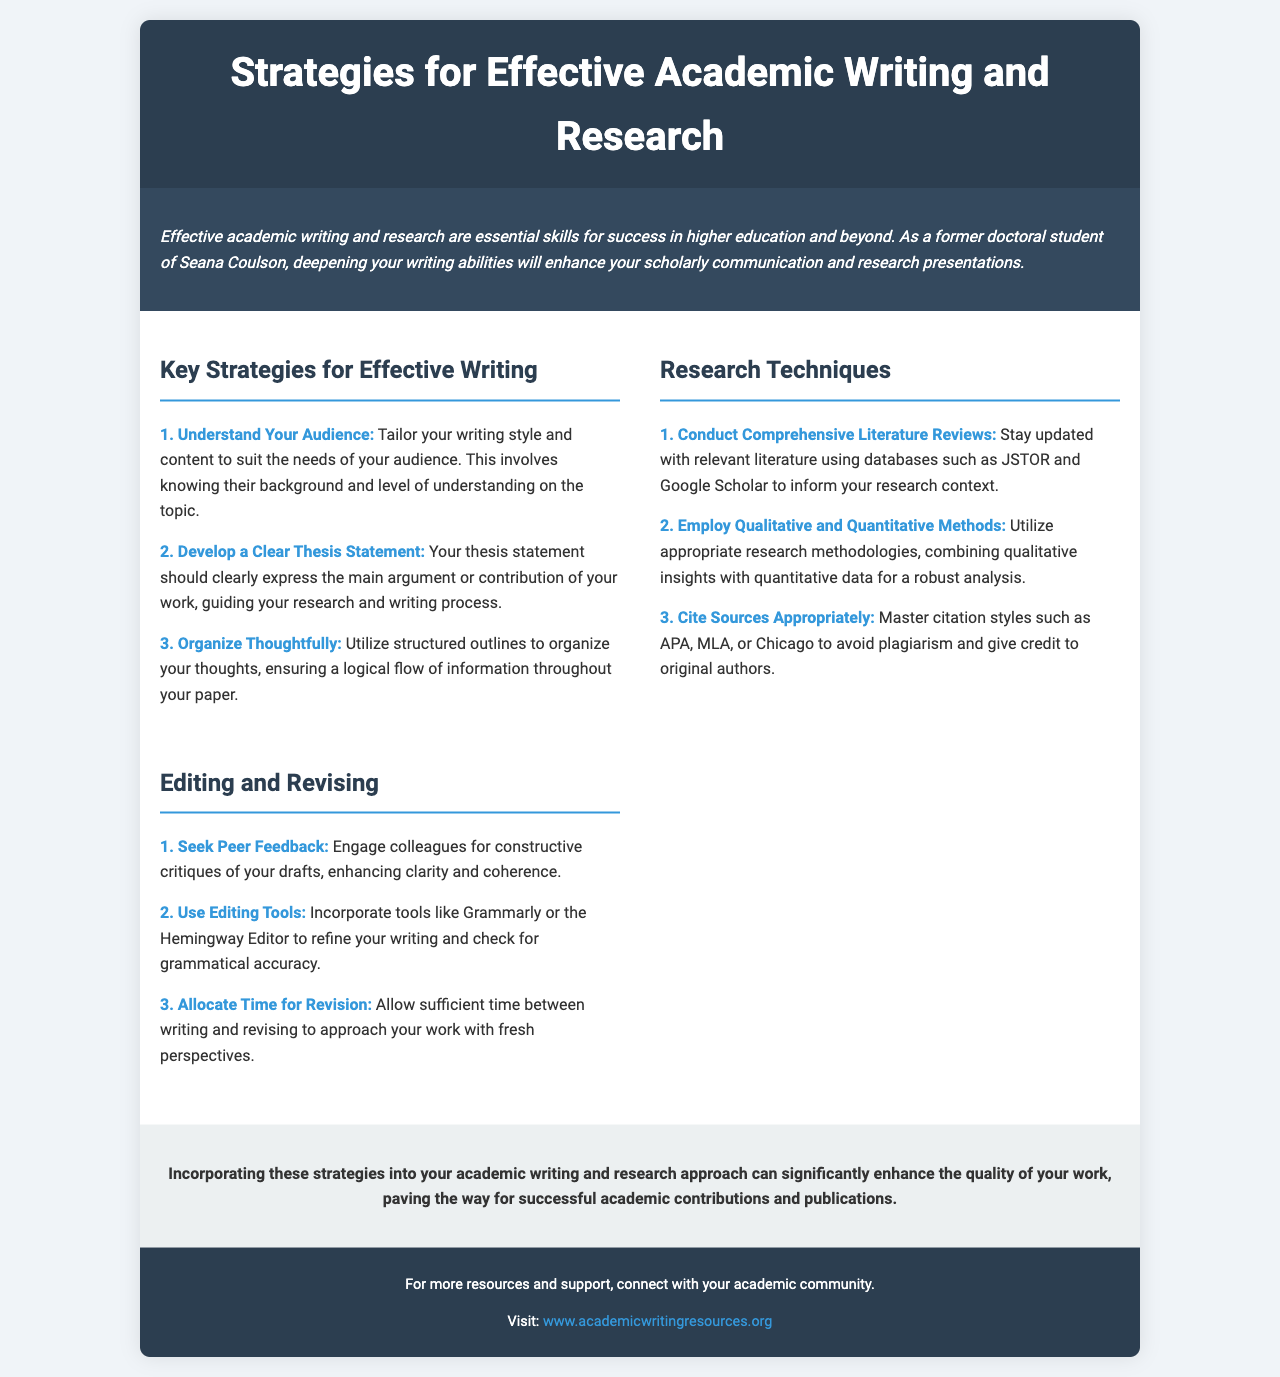What are the key strategies for effective writing? The section titled "Key Strategies for Effective Writing" lists three key strategies.
Answer: Understand Your Audience, Develop a Clear Thesis Statement, Organize Thoughtfully What is the purpose of a thesis statement? The document explains that the thesis statement should express the main argument or contribution of your work.
Answer: Main argument or contribution Which citation styles are mentioned? The document lists citation styles to master in order to avoid plagiarism.
Answer: APA, MLA, Chicago What should you do to enhance clarity and coherence? The section on Editing and Revising recommends seeking input from colleagues.
Answer: Seek Peer Feedback How many research techniques are listed in the document? The "Research Techniques" section outlines three distinct techniques.
Answer: Three What is the suggested tool for refining writing? The document includes a suggestion to employ tools that enhance writing quality.
Answer: Grammarly How does the document describe the editing process? The section on Editing and Revising indicates various approaches to improve drafts.
Answer: Seek feedback, use tools, allocate time What might be a reason to connect with your academic community? The footer suggests that engaging with the academic community can provide further resources and support.
Answer: Resources and support 